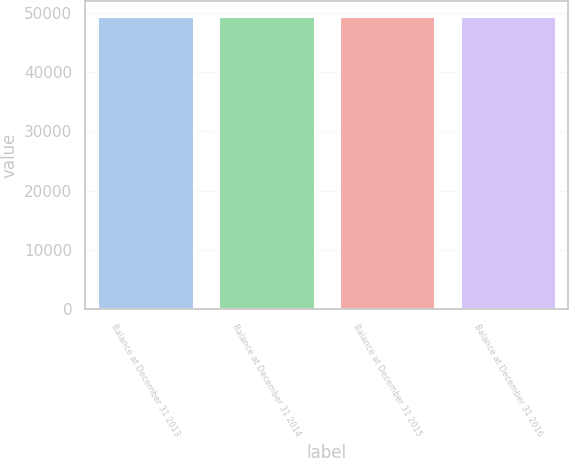<chart> <loc_0><loc_0><loc_500><loc_500><bar_chart><fcel>Balance at December 31 2013<fcel>Balance at December 31 2014<fcel>Balance at December 31 2015<fcel>Balance at December 31 2016<nl><fcel>49452<fcel>49452.1<fcel>49452.2<fcel>49452.3<nl></chart> 